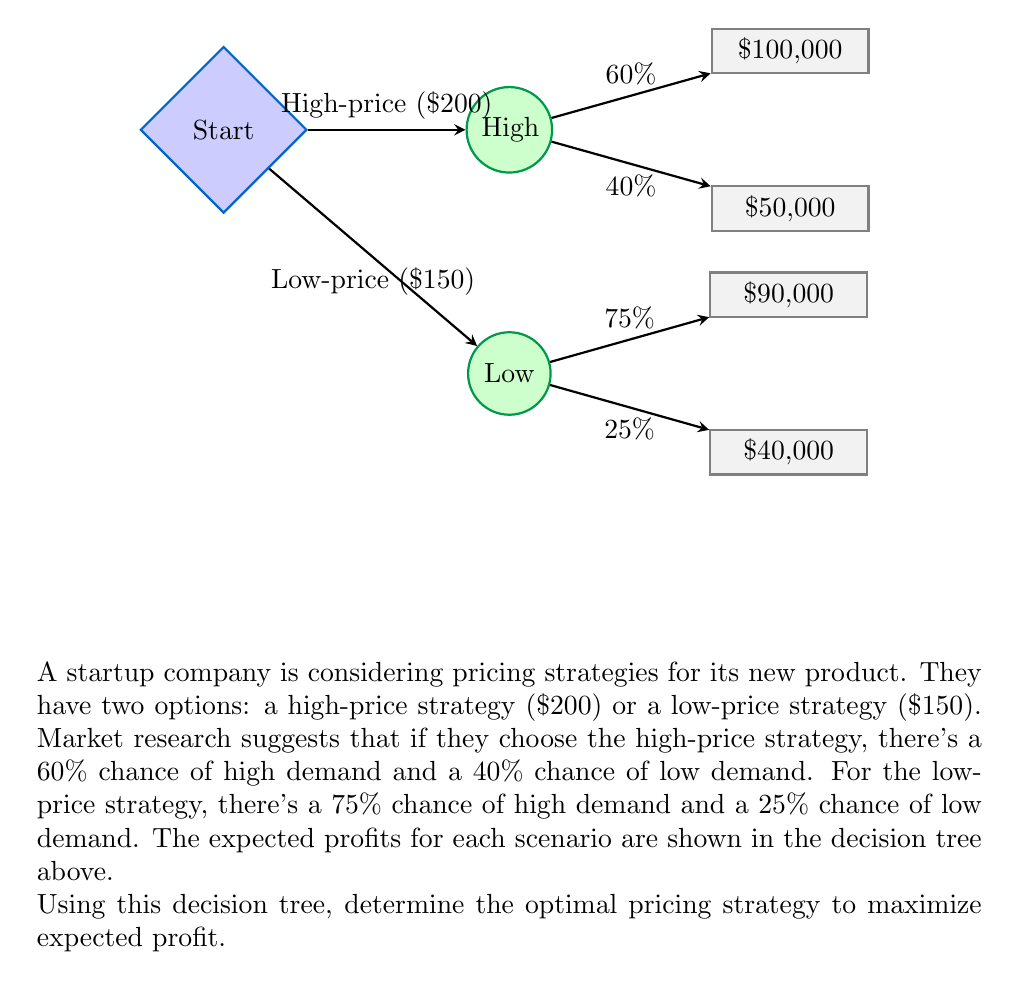Provide a solution to this math problem. Let's solve this problem step-by-step using the decision tree method:

1. Calculate the expected value for the high-price strategy:
   $$ EV(\text{High-price}) = 0.60 \times \$100,000 + 0.40 \times \$50,000 $$
   $$ = \$60,000 + \$20,000 = \$80,000 $$

2. Calculate the expected value for the low-price strategy:
   $$ EV(\text{Low-price}) = 0.75 \times \$90,000 + 0.25 \times \$40,000 $$
   $$ = \$67,500 + \$10,000 = \$77,500 $$

3. Compare the expected values:
   The high-price strategy has a higher expected value ($80,000) compared to the low-price strategy ($77,500).

4. Decision:
   Choose the strategy with the highest expected value to maximize profit.
Answer: High-price strategy ($80,000 expected profit) 